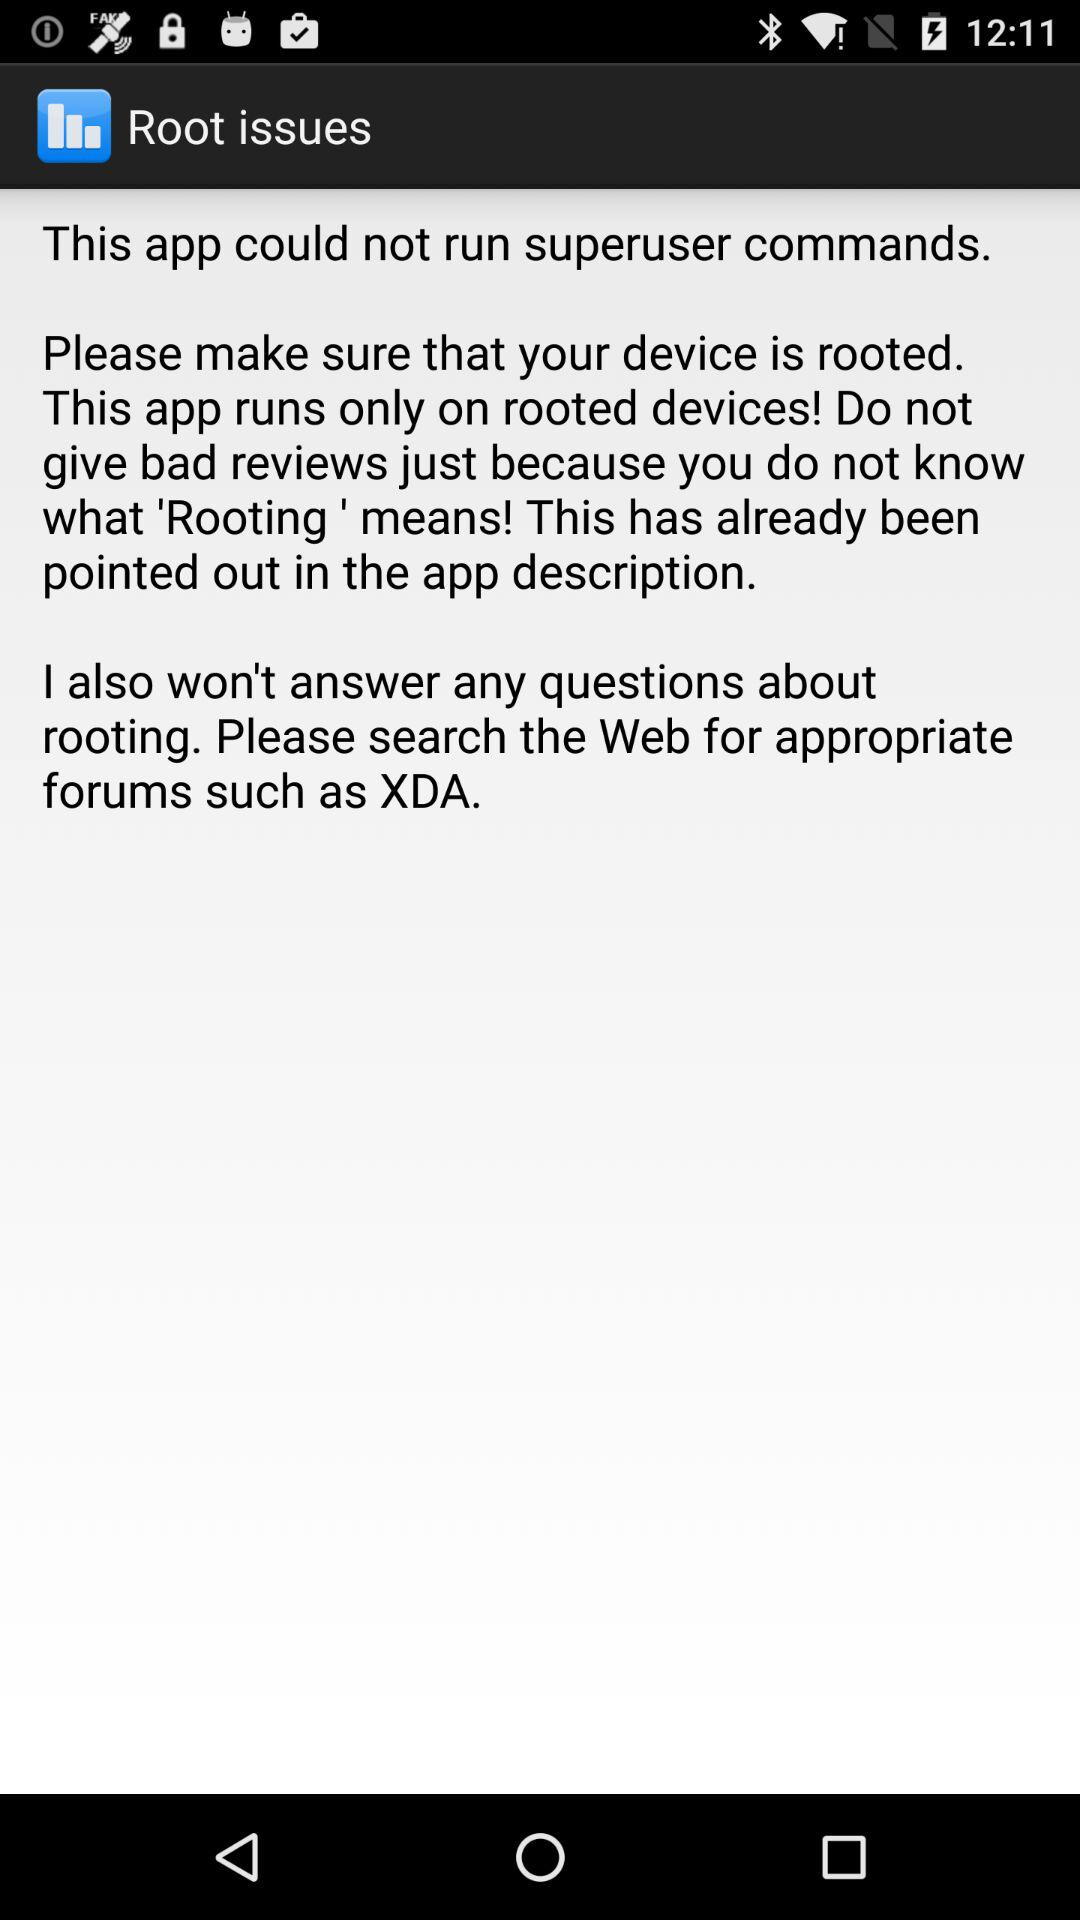How many text blocks are in the app error message?
Answer the question using a single word or phrase. 3 